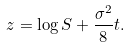<formula> <loc_0><loc_0><loc_500><loc_500>z = \log S + \frac { \sigma ^ { 2 } } { 8 } t .</formula> 